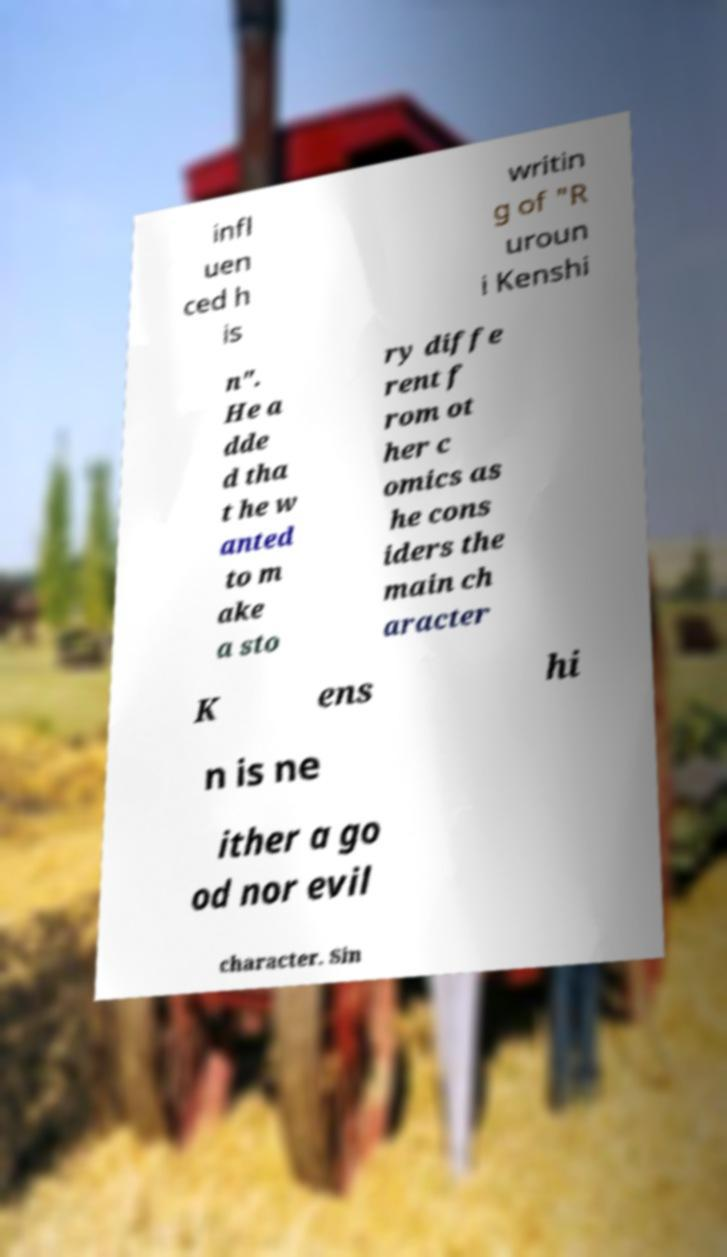What messages or text are displayed in this image? I need them in a readable, typed format. infl uen ced h is writin g of "R uroun i Kenshi n". He a dde d tha t he w anted to m ake a sto ry diffe rent f rom ot her c omics as he cons iders the main ch aracter K ens hi n is ne ither a go od nor evil character. Sin 